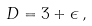Convert formula to latex. <formula><loc_0><loc_0><loc_500><loc_500>D = 3 + \epsilon \, ,</formula> 